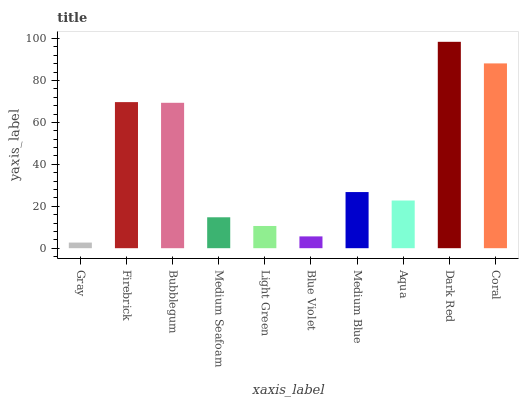Is Gray the minimum?
Answer yes or no. Yes. Is Dark Red the maximum?
Answer yes or no. Yes. Is Firebrick the minimum?
Answer yes or no. No. Is Firebrick the maximum?
Answer yes or no. No. Is Firebrick greater than Gray?
Answer yes or no. Yes. Is Gray less than Firebrick?
Answer yes or no. Yes. Is Gray greater than Firebrick?
Answer yes or no. No. Is Firebrick less than Gray?
Answer yes or no. No. Is Medium Blue the high median?
Answer yes or no. Yes. Is Aqua the low median?
Answer yes or no. Yes. Is Blue Violet the high median?
Answer yes or no. No. Is Bubblegum the low median?
Answer yes or no. No. 